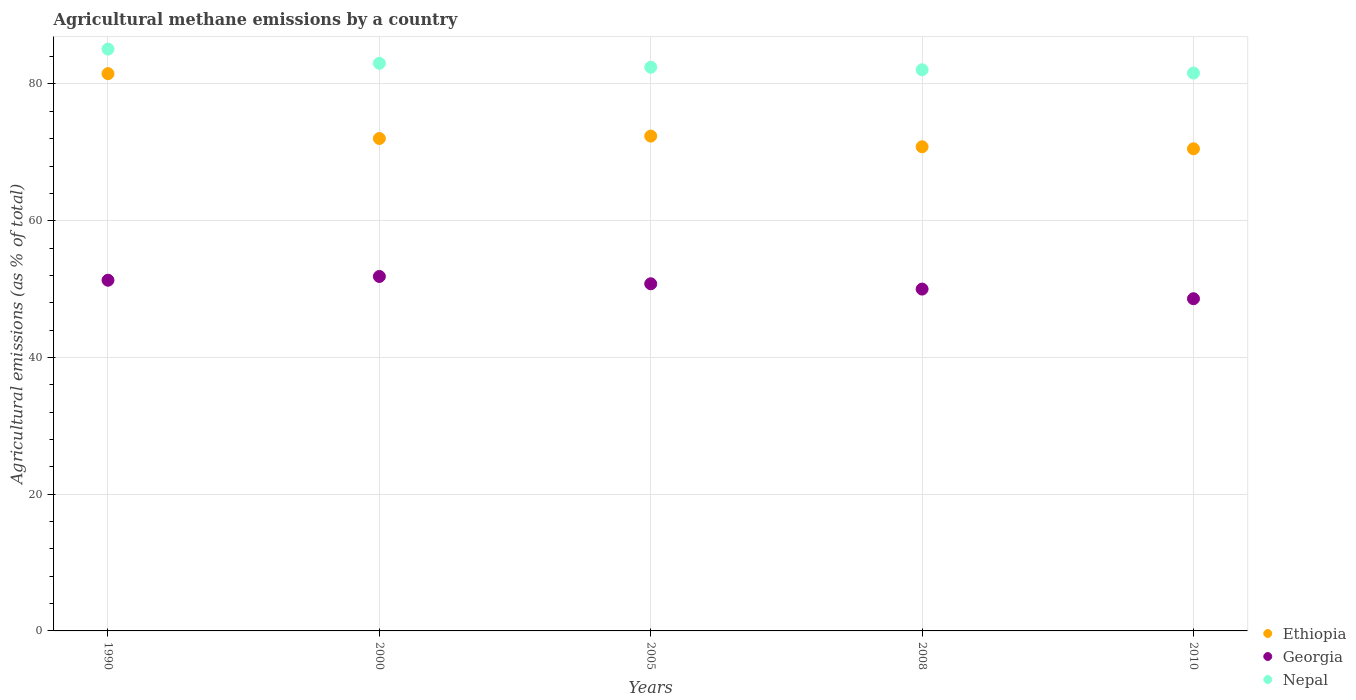How many different coloured dotlines are there?
Your answer should be very brief. 3. Is the number of dotlines equal to the number of legend labels?
Make the answer very short. Yes. What is the amount of agricultural methane emitted in Georgia in 2000?
Give a very brief answer. 51.84. Across all years, what is the maximum amount of agricultural methane emitted in Ethiopia?
Give a very brief answer. 81.5. Across all years, what is the minimum amount of agricultural methane emitted in Ethiopia?
Give a very brief answer. 70.52. In which year was the amount of agricultural methane emitted in Nepal minimum?
Your answer should be compact. 2010. What is the total amount of agricultural methane emitted in Ethiopia in the graph?
Keep it short and to the point. 367.23. What is the difference between the amount of agricultural methane emitted in Georgia in 2000 and that in 2010?
Offer a very short reply. 3.26. What is the difference between the amount of agricultural methane emitted in Georgia in 2000 and the amount of agricultural methane emitted in Ethiopia in 2010?
Give a very brief answer. -18.67. What is the average amount of agricultural methane emitted in Georgia per year?
Give a very brief answer. 50.5. In the year 2008, what is the difference between the amount of agricultural methane emitted in Georgia and amount of agricultural methane emitted in Ethiopia?
Offer a very short reply. -20.81. In how many years, is the amount of agricultural methane emitted in Ethiopia greater than 24 %?
Provide a succinct answer. 5. What is the ratio of the amount of agricultural methane emitted in Ethiopia in 2005 to that in 2010?
Your answer should be very brief. 1.03. Is the amount of agricultural methane emitted in Nepal in 1990 less than that in 2010?
Give a very brief answer. No. What is the difference between the highest and the second highest amount of agricultural methane emitted in Georgia?
Your answer should be very brief. 0.55. What is the difference between the highest and the lowest amount of agricultural methane emitted in Ethiopia?
Your response must be concise. 10.99. Does the amount of agricultural methane emitted in Ethiopia monotonically increase over the years?
Offer a terse response. No. Is the amount of agricultural methane emitted in Georgia strictly greater than the amount of agricultural methane emitted in Ethiopia over the years?
Your answer should be compact. No. How many years are there in the graph?
Give a very brief answer. 5. What is the difference between two consecutive major ticks on the Y-axis?
Give a very brief answer. 20. Are the values on the major ticks of Y-axis written in scientific E-notation?
Your answer should be very brief. No. Does the graph contain grids?
Provide a short and direct response. Yes. What is the title of the graph?
Your response must be concise. Agricultural methane emissions by a country. What is the label or title of the Y-axis?
Your answer should be very brief. Agricultural emissions (as % of total). What is the Agricultural emissions (as % of total) of Ethiopia in 1990?
Make the answer very short. 81.5. What is the Agricultural emissions (as % of total) in Georgia in 1990?
Provide a short and direct response. 51.29. What is the Agricultural emissions (as % of total) of Nepal in 1990?
Your answer should be compact. 85.1. What is the Agricultural emissions (as % of total) of Ethiopia in 2000?
Give a very brief answer. 72.02. What is the Agricultural emissions (as % of total) in Georgia in 2000?
Provide a succinct answer. 51.84. What is the Agricultural emissions (as % of total) of Nepal in 2000?
Ensure brevity in your answer.  83.02. What is the Agricultural emissions (as % of total) in Ethiopia in 2005?
Give a very brief answer. 72.38. What is the Agricultural emissions (as % of total) of Georgia in 2005?
Offer a very short reply. 50.77. What is the Agricultural emissions (as % of total) in Nepal in 2005?
Your response must be concise. 82.45. What is the Agricultural emissions (as % of total) of Ethiopia in 2008?
Offer a terse response. 70.81. What is the Agricultural emissions (as % of total) of Georgia in 2008?
Offer a very short reply. 50. What is the Agricultural emissions (as % of total) of Nepal in 2008?
Offer a very short reply. 82.08. What is the Agricultural emissions (as % of total) in Ethiopia in 2010?
Your response must be concise. 70.52. What is the Agricultural emissions (as % of total) of Georgia in 2010?
Keep it short and to the point. 48.59. What is the Agricultural emissions (as % of total) of Nepal in 2010?
Provide a succinct answer. 81.6. Across all years, what is the maximum Agricultural emissions (as % of total) in Ethiopia?
Provide a short and direct response. 81.5. Across all years, what is the maximum Agricultural emissions (as % of total) in Georgia?
Offer a terse response. 51.84. Across all years, what is the maximum Agricultural emissions (as % of total) of Nepal?
Your answer should be very brief. 85.1. Across all years, what is the minimum Agricultural emissions (as % of total) in Ethiopia?
Keep it short and to the point. 70.52. Across all years, what is the minimum Agricultural emissions (as % of total) in Georgia?
Offer a terse response. 48.59. Across all years, what is the minimum Agricultural emissions (as % of total) in Nepal?
Make the answer very short. 81.6. What is the total Agricultural emissions (as % of total) of Ethiopia in the graph?
Offer a terse response. 367.23. What is the total Agricultural emissions (as % of total) in Georgia in the graph?
Offer a very short reply. 252.5. What is the total Agricultural emissions (as % of total) of Nepal in the graph?
Make the answer very short. 414.25. What is the difference between the Agricultural emissions (as % of total) in Ethiopia in 1990 and that in 2000?
Make the answer very short. 9.48. What is the difference between the Agricultural emissions (as % of total) of Georgia in 1990 and that in 2000?
Keep it short and to the point. -0.55. What is the difference between the Agricultural emissions (as % of total) of Nepal in 1990 and that in 2000?
Your response must be concise. 2.08. What is the difference between the Agricultural emissions (as % of total) in Ethiopia in 1990 and that in 2005?
Your answer should be very brief. 9.13. What is the difference between the Agricultural emissions (as % of total) in Georgia in 1990 and that in 2005?
Offer a very short reply. 0.52. What is the difference between the Agricultural emissions (as % of total) in Nepal in 1990 and that in 2005?
Keep it short and to the point. 2.66. What is the difference between the Agricultural emissions (as % of total) of Ethiopia in 1990 and that in 2008?
Provide a short and direct response. 10.69. What is the difference between the Agricultural emissions (as % of total) of Georgia in 1990 and that in 2008?
Provide a succinct answer. 1.3. What is the difference between the Agricultural emissions (as % of total) of Nepal in 1990 and that in 2008?
Your answer should be compact. 3.03. What is the difference between the Agricultural emissions (as % of total) in Ethiopia in 1990 and that in 2010?
Offer a very short reply. 10.99. What is the difference between the Agricultural emissions (as % of total) in Georgia in 1990 and that in 2010?
Your answer should be very brief. 2.71. What is the difference between the Agricultural emissions (as % of total) of Nepal in 1990 and that in 2010?
Give a very brief answer. 3.51. What is the difference between the Agricultural emissions (as % of total) in Ethiopia in 2000 and that in 2005?
Provide a short and direct response. -0.35. What is the difference between the Agricultural emissions (as % of total) in Georgia in 2000 and that in 2005?
Your response must be concise. 1.07. What is the difference between the Agricultural emissions (as % of total) of Nepal in 2000 and that in 2005?
Your answer should be compact. 0.58. What is the difference between the Agricultural emissions (as % of total) in Ethiopia in 2000 and that in 2008?
Give a very brief answer. 1.21. What is the difference between the Agricultural emissions (as % of total) of Georgia in 2000 and that in 2008?
Offer a terse response. 1.85. What is the difference between the Agricultural emissions (as % of total) of Nepal in 2000 and that in 2008?
Provide a short and direct response. 0.95. What is the difference between the Agricultural emissions (as % of total) in Ethiopia in 2000 and that in 2010?
Keep it short and to the point. 1.51. What is the difference between the Agricultural emissions (as % of total) of Georgia in 2000 and that in 2010?
Your response must be concise. 3.26. What is the difference between the Agricultural emissions (as % of total) of Nepal in 2000 and that in 2010?
Give a very brief answer. 1.43. What is the difference between the Agricultural emissions (as % of total) in Ethiopia in 2005 and that in 2008?
Your answer should be very brief. 1.56. What is the difference between the Agricultural emissions (as % of total) of Georgia in 2005 and that in 2008?
Your answer should be very brief. 0.77. What is the difference between the Agricultural emissions (as % of total) of Nepal in 2005 and that in 2008?
Make the answer very short. 0.37. What is the difference between the Agricultural emissions (as % of total) in Ethiopia in 2005 and that in 2010?
Provide a short and direct response. 1.86. What is the difference between the Agricultural emissions (as % of total) in Georgia in 2005 and that in 2010?
Give a very brief answer. 2.18. What is the difference between the Agricultural emissions (as % of total) of Nepal in 2005 and that in 2010?
Your answer should be very brief. 0.85. What is the difference between the Agricultural emissions (as % of total) in Ethiopia in 2008 and that in 2010?
Your answer should be compact. 0.29. What is the difference between the Agricultural emissions (as % of total) in Georgia in 2008 and that in 2010?
Your answer should be very brief. 1.41. What is the difference between the Agricultural emissions (as % of total) of Nepal in 2008 and that in 2010?
Offer a terse response. 0.48. What is the difference between the Agricultural emissions (as % of total) in Ethiopia in 1990 and the Agricultural emissions (as % of total) in Georgia in 2000?
Provide a short and direct response. 29.66. What is the difference between the Agricultural emissions (as % of total) of Ethiopia in 1990 and the Agricultural emissions (as % of total) of Nepal in 2000?
Keep it short and to the point. -1.52. What is the difference between the Agricultural emissions (as % of total) in Georgia in 1990 and the Agricultural emissions (as % of total) in Nepal in 2000?
Your answer should be very brief. -31.73. What is the difference between the Agricultural emissions (as % of total) of Ethiopia in 1990 and the Agricultural emissions (as % of total) of Georgia in 2005?
Provide a succinct answer. 30.73. What is the difference between the Agricultural emissions (as % of total) in Ethiopia in 1990 and the Agricultural emissions (as % of total) in Nepal in 2005?
Give a very brief answer. -0.94. What is the difference between the Agricultural emissions (as % of total) in Georgia in 1990 and the Agricultural emissions (as % of total) in Nepal in 2005?
Ensure brevity in your answer.  -31.15. What is the difference between the Agricultural emissions (as % of total) of Ethiopia in 1990 and the Agricultural emissions (as % of total) of Georgia in 2008?
Give a very brief answer. 31.51. What is the difference between the Agricultural emissions (as % of total) in Ethiopia in 1990 and the Agricultural emissions (as % of total) in Nepal in 2008?
Keep it short and to the point. -0.57. What is the difference between the Agricultural emissions (as % of total) of Georgia in 1990 and the Agricultural emissions (as % of total) of Nepal in 2008?
Your answer should be very brief. -30.78. What is the difference between the Agricultural emissions (as % of total) of Ethiopia in 1990 and the Agricultural emissions (as % of total) of Georgia in 2010?
Make the answer very short. 32.92. What is the difference between the Agricultural emissions (as % of total) in Ethiopia in 1990 and the Agricultural emissions (as % of total) in Nepal in 2010?
Ensure brevity in your answer.  -0.09. What is the difference between the Agricultural emissions (as % of total) in Georgia in 1990 and the Agricultural emissions (as % of total) in Nepal in 2010?
Offer a very short reply. -30.3. What is the difference between the Agricultural emissions (as % of total) of Ethiopia in 2000 and the Agricultural emissions (as % of total) of Georgia in 2005?
Offer a very short reply. 21.25. What is the difference between the Agricultural emissions (as % of total) of Ethiopia in 2000 and the Agricultural emissions (as % of total) of Nepal in 2005?
Provide a succinct answer. -10.42. What is the difference between the Agricultural emissions (as % of total) of Georgia in 2000 and the Agricultural emissions (as % of total) of Nepal in 2005?
Keep it short and to the point. -30.6. What is the difference between the Agricultural emissions (as % of total) in Ethiopia in 2000 and the Agricultural emissions (as % of total) in Georgia in 2008?
Offer a terse response. 22.03. What is the difference between the Agricultural emissions (as % of total) in Ethiopia in 2000 and the Agricultural emissions (as % of total) in Nepal in 2008?
Your response must be concise. -10.05. What is the difference between the Agricultural emissions (as % of total) of Georgia in 2000 and the Agricultural emissions (as % of total) of Nepal in 2008?
Your response must be concise. -30.23. What is the difference between the Agricultural emissions (as % of total) in Ethiopia in 2000 and the Agricultural emissions (as % of total) in Georgia in 2010?
Your response must be concise. 23.43. What is the difference between the Agricultural emissions (as % of total) of Ethiopia in 2000 and the Agricultural emissions (as % of total) of Nepal in 2010?
Offer a terse response. -9.57. What is the difference between the Agricultural emissions (as % of total) of Georgia in 2000 and the Agricultural emissions (as % of total) of Nepal in 2010?
Provide a succinct answer. -29.75. What is the difference between the Agricultural emissions (as % of total) of Ethiopia in 2005 and the Agricultural emissions (as % of total) of Georgia in 2008?
Provide a succinct answer. 22.38. What is the difference between the Agricultural emissions (as % of total) in Ethiopia in 2005 and the Agricultural emissions (as % of total) in Nepal in 2008?
Give a very brief answer. -9.7. What is the difference between the Agricultural emissions (as % of total) of Georgia in 2005 and the Agricultural emissions (as % of total) of Nepal in 2008?
Make the answer very short. -31.31. What is the difference between the Agricultural emissions (as % of total) in Ethiopia in 2005 and the Agricultural emissions (as % of total) in Georgia in 2010?
Your answer should be compact. 23.79. What is the difference between the Agricultural emissions (as % of total) in Ethiopia in 2005 and the Agricultural emissions (as % of total) in Nepal in 2010?
Give a very brief answer. -9.22. What is the difference between the Agricultural emissions (as % of total) of Georgia in 2005 and the Agricultural emissions (as % of total) of Nepal in 2010?
Ensure brevity in your answer.  -30.82. What is the difference between the Agricultural emissions (as % of total) of Ethiopia in 2008 and the Agricultural emissions (as % of total) of Georgia in 2010?
Your response must be concise. 22.22. What is the difference between the Agricultural emissions (as % of total) in Ethiopia in 2008 and the Agricultural emissions (as % of total) in Nepal in 2010?
Your answer should be very brief. -10.78. What is the difference between the Agricultural emissions (as % of total) of Georgia in 2008 and the Agricultural emissions (as % of total) of Nepal in 2010?
Ensure brevity in your answer.  -31.6. What is the average Agricultural emissions (as % of total) of Ethiopia per year?
Offer a terse response. 73.45. What is the average Agricultural emissions (as % of total) of Georgia per year?
Provide a short and direct response. 50.5. What is the average Agricultural emissions (as % of total) of Nepal per year?
Offer a terse response. 82.85. In the year 1990, what is the difference between the Agricultural emissions (as % of total) of Ethiopia and Agricultural emissions (as % of total) of Georgia?
Make the answer very short. 30.21. In the year 1990, what is the difference between the Agricultural emissions (as % of total) of Ethiopia and Agricultural emissions (as % of total) of Nepal?
Keep it short and to the point. -3.6. In the year 1990, what is the difference between the Agricultural emissions (as % of total) of Georgia and Agricultural emissions (as % of total) of Nepal?
Provide a short and direct response. -33.81. In the year 2000, what is the difference between the Agricultural emissions (as % of total) of Ethiopia and Agricultural emissions (as % of total) of Georgia?
Your response must be concise. 20.18. In the year 2000, what is the difference between the Agricultural emissions (as % of total) of Ethiopia and Agricultural emissions (as % of total) of Nepal?
Keep it short and to the point. -11. In the year 2000, what is the difference between the Agricultural emissions (as % of total) in Georgia and Agricultural emissions (as % of total) in Nepal?
Offer a very short reply. -31.18. In the year 2005, what is the difference between the Agricultural emissions (as % of total) of Ethiopia and Agricultural emissions (as % of total) of Georgia?
Your response must be concise. 21.6. In the year 2005, what is the difference between the Agricultural emissions (as % of total) of Ethiopia and Agricultural emissions (as % of total) of Nepal?
Your answer should be very brief. -10.07. In the year 2005, what is the difference between the Agricultural emissions (as % of total) in Georgia and Agricultural emissions (as % of total) in Nepal?
Your response must be concise. -31.67. In the year 2008, what is the difference between the Agricultural emissions (as % of total) in Ethiopia and Agricultural emissions (as % of total) in Georgia?
Your answer should be very brief. 20.81. In the year 2008, what is the difference between the Agricultural emissions (as % of total) in Ethiopia and Agricultural emissions (as % of total) in Nepal?
Provide a succinct answer. -11.27. In the year 2008, what is the difference between the Agricultural emissions (as % of total) of Georgia and Agricultural emissions (as % of total) of Nepal?
Offer a terse response. -32.08. In the year 2010, what is the difference between the Agricultural emissions (as % of total) in Ethiopia and Agricultural emissions (as % of total) in Georgia?
Offer a terse response. 21.93. In the year 2010, what is the difference between the Agricultural emissions (as % of total) of Ethiopia and Agricultural emissions (as % of total) of Nepal?
Ensure brevity in your answer.  -11.08. In the year 2010, what is the difference between the Agricultural emissions (as % of total) of Georgia and Agricultural emissions (as % of total) of Nepal?
Provide a short and direct response. -33.01. What is the ratio of the Agricultural emissions (as % of total) of Ethiopia in 1990 to that in 2000?
Offer a terse response. 1.13. What is the ratio of the Agricultural emissions (as % of total) of Georgia in 1990 to that in 2000?
Ensure brevity in your answer.  0.99. What is the ratio of the Agricultural emissions (as % of total) in Nepal in 1990 to that in 2000?
Your answer should be very brief. 1.03. What is the ratio of the Agricultural emissions (as % of total) in Ethiopia in 1990 to that in 2005?
Provide a short and direct response. 1.13. What is the ratio of the Agricultural emissions (as % of total) in Georgia in 1990 to that in 2005?
Your answer should be compact. 1.01. What is the ratio of the Agricultural emissions (as % of total) of Nepal in 1990 to that in 2005?
Give a very brief answer. 1.03. What is the ratio of the Agricultural emissions (as % of total) in Ethiopia in 1990 to that in 2008?
Your answer should be compact. 1.15. What is the ratio of the Agricultural emissions (as % of total) of Georgia in 1990 to that in 2008?
Provide a succinct answer. 1.03. What is the ratio of the Agricultural emissions (as % of total) in Nepal in 1990 to that in 2008?
Offer a very short reply. 1.04. What is the ratio of the Agricultural emissions (as % of total) in Ethiopia in 1990 to that in 2010?
Your answer should be compact. 1.16. What is the ratio of the Agricultural emissions (as % of total) in Georgia in 1990 to that in 2010?
Keep it short and to the point. 1.06. What is the ratio of the Agricultural emissions (as % of total) in Nepal in 1990 to that in 2010?
Provide a succinct answer. 1.04. What is the ratio of the Agricultural emissions (as % of total) of Ethiopia in 2000 to that in 2005?
Ensure brevity in your answer.  1. What is the ratio of the Agricultural emissions (as % of total) of Georgia in 2000 to that in 2005?
Provide a short and direct response. 1.02. What is the ratio of the Agricultural emissions (as % of total) in Nepal in 2000 to that in 2005?
Your answer should be compact. 1.01. What is the ratio of the Agricultural emissions (as % of total) of Ethiopia in 2000 to that in 2008?
Your answer should be very brief. 1.02. What is the ratio of the Agricultural emissions (as % of total) of Georgia in 2000 to that in 2008?
Give a very brief answer. 1.04. What is the ratio of the Agricultural emissions (as % of total) of Nepal in 2000 to that in 2008?
Provide a short and direct response. 1.01. What is the ratio of the Agricultural emissions (as % of total) of Ethiopia in 2000 to that in 2010?
Your answer should be very brief. 1.02. What is the ratio of the Agricultural emissions (as % of total) of Georgia in 2000 to that in 2010?
Provide a succinct answer. 1.07. What is the ratio of the Agricultural emissions (as % of total) in Nepal in 2000 to that in 2010?
Provide a short and direct response. 1.02. What is the ratio of the Agricultural emissions (as % of total) in Ethiopia in 2005 to that in 2008?
Offer a very short reply. 1.02. What is the ratio of the Agricultural emissions (as % of total) of Georgia in 2005 to that in 2008?
Make the answer very short. 1.02. What is the ratio of the Agricultural emissions (as % of total) in Ethiopia in 2005 to that in 2010?
Your answer should be very brief. 1.03. What is the ratio of the Agricultural emissions (as % of total) in Georgia in 2005 to that in 2010?
Keep it short and to the point. 1.04. What is the ratio of the Agricultural emissions (as % of total) of Nepal in 2005 to that in 2010?
Your answer should be very brief. 1.01. What is the ratio of the Agricultural emissions (as % of total) in Nepal in 2008 to that in 2010?
Provide a succinct answer. 1.01. What is the difference between the highest and the second highest Agricultural emissions (as % of total) in Ethiopia?
Ensure brevity in your answer.  9.13. What is the difference between the highest and the second highest Agricultural emissions (as % of total) in Georgia?
Your answer should be very brief. 0.55. What is the difference between the highest and the second highest Agricultural emissions (as % of total) in Nepal?
Provide a short and direct response. 2.08. What is the difference between the highest and the lowest Agricultural emissions (as % of total) of Ethiopia?
Your response must be concise. 10.99. What is the difference between the highest and the lowest Agricultural emissions (as % of total) in Georgia?
Keep it short and to the point. 3.26. What is the difference between the highest and the lowest Agricultural emissions (as % of total) in Nepal?
Ensure brevity in your answer.  3.51. 